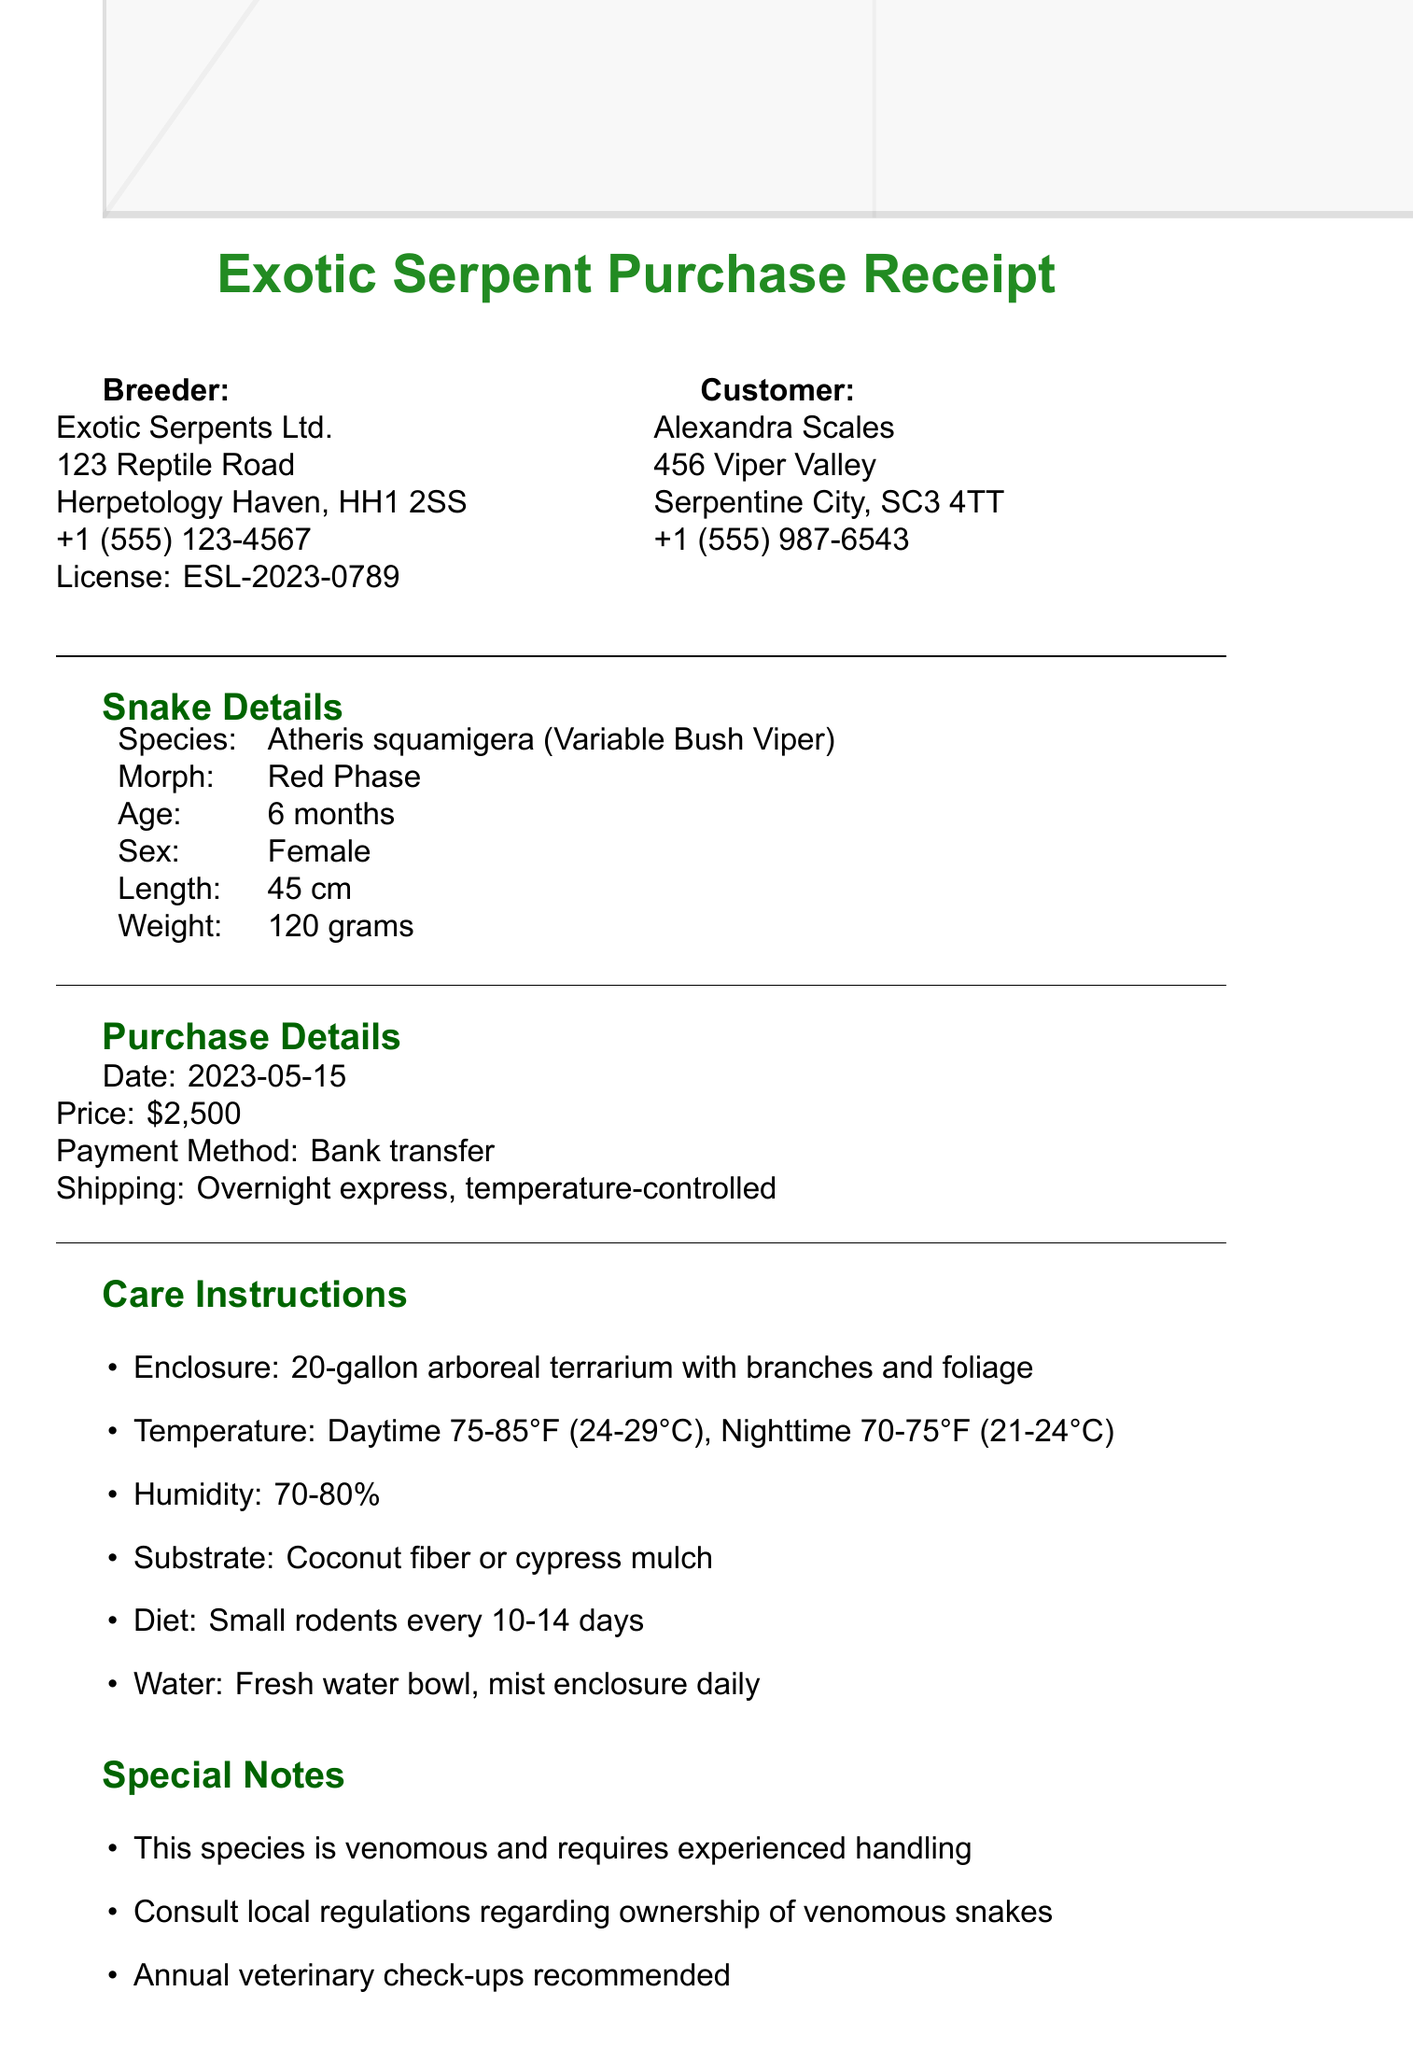What is the name of the breeder? The name of the breeder is listed at the top of the document as Exotic Serpents Ltd.
Answer: Exotic Serpents Ltd What species of snake was purchased? The species of snake is specified in the snake details section of the document as Atheris squamigera.
Answer: Atheris squamigera What is the age of the snake? The age of the snake is provided in the snake details section, marked as 6 months.
Answer: 6 months What is the price of the snake? The price is outlined in the purchase details section of the document as $2,500.
Answer: $2,500 What type of enclosure is recommended? The care instructions state that a 20-gallon arboreal terrarium with branches and foliage is recommended.
Answer: 20-gallon arboreal terrarium with branches and foliage What kind of diet does the snake require? The diet information specifies that the snake should be fed small rodents every 10-14 days.
Answer: Small rodents every 10-14 days How long is the health guarantee? The warranty section details that the health guarantee lasts for 14 days.
Answer: 14 days Is this species venomous? There is a note in the care instructions indicating that this species is venomous and requires experienced handling.
Answer: Yes What is included with the purchase? The included items section details all items provided, such as the Certificate of Authenticity and feeding tongs.
Answer: Certificate of Authenticity, Feeding tongs, Care guide booklet, 30-day supply of frozen rodents 